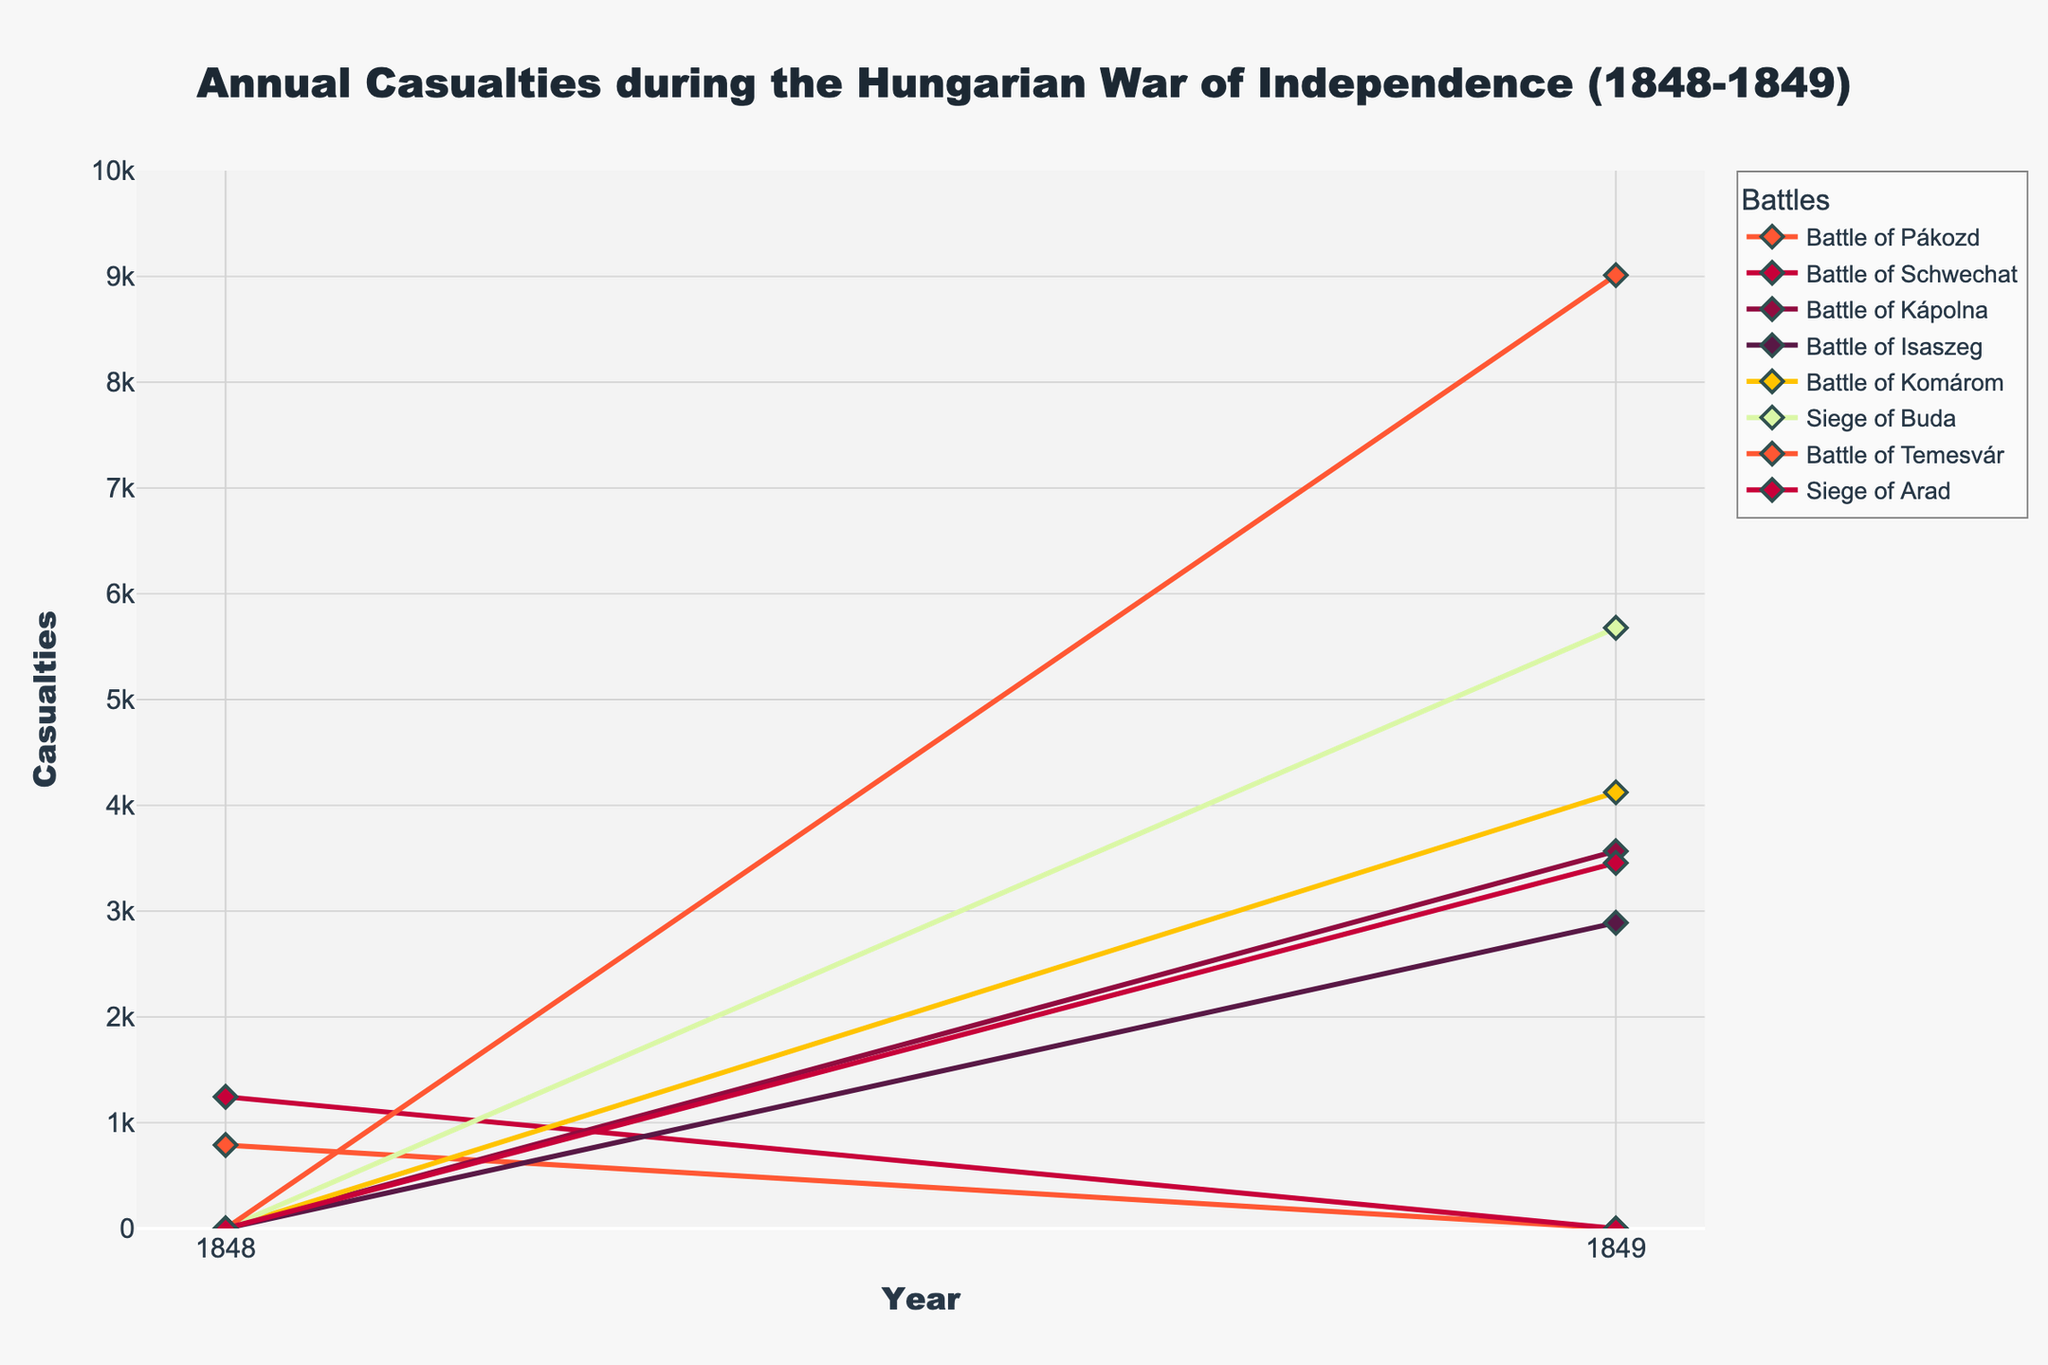What year did the Battle of Pákozd and the Battle of Schwechat occur? Both the Battle of Pákozd and the Battle of Schwechat occurred in 1848, as indicated by the non-zero casualties in that year only for these battles.
Answer: 1848 Which battle had the highest casualties in 1849? To find the highest casualties in 1849, we need to compare the values for all battles in that year. The highest value is for the Battle of Temesvár with 9012 casualties.
Answer: Battle of Temesvár How many more casualties occurred in the Siege of Buda compared to the Battle of Isaszeg in 1849? For 1849, the Siege of Buda had 5678 casualties and the Battle of Isaszeg had 2890 casualties. The difference is calculated as 5678 - 2890.
Answer: 2788 What is the total number of casualties across all battles in 1849? The sum of the casualties in 1849 is calculated as 3567 (Kápolna) + 2890 (Isaszeg) + 4123 (Komárom) + 5678 (Buda) + 9012 (Temesvár) + 3456 (Arad). The total is 28726.
Answer: 28726 Which battles only had casualties reported in a single year, and which year was it? By observing the data, we see that the Battle of Pákozd and the Battle of Schwechat only had casualties in 1848, while the battles of Kápolna, Isaszeg, Komárom, Buda, Temesvár, and Arad only had casualties in 1849.
Answer: Pákozd and Schwechat in 1848, Kápolna, Isaszeg, Komárom, Buda, Temesvár, and Arad in 1849 Comparing the casualties in 1848, which battle had more casualties, Pákozd or Schwechat? In 1848, the Battle of Pákozd had 789 casualties while the Battle of Schwechat had 1245 casualties. Therefore, Schwechat had more casualties.
Answer: Battle of Schwechat What was the combined number of casualties for the Battle of Komárom and the Siege of Arad in 1849? The Battle of Komárom had 4123 casualties and the Siege of Arad had 3456 casualties in 1849. The combined number is 4123 + 3456.
Answer: 7579 How many battles had over 4000 casualties in 1849? Name them. The battles with over 4000 casualties in 1849 are Komárom (4123 casualties), Buda (5678 casualties), and Temesvár (9012 casualties).
Answer: Three battles: Komárom, Buda, Temesvár Which battle had the lowest number of casualties in 1849? By comparing the casualties of all battles in 1849, the Battle of Isaszeg had the lowest number with 2890 casualties.
Answer: Battle of Isaszeg What is the average number of casualties for the battles occurring in 1848? In 1848, the casualties were 789 for Pákozd and 1245 for Schwechat. The average is calculated as (789 + 1245) / 2.
Answer: 1017 